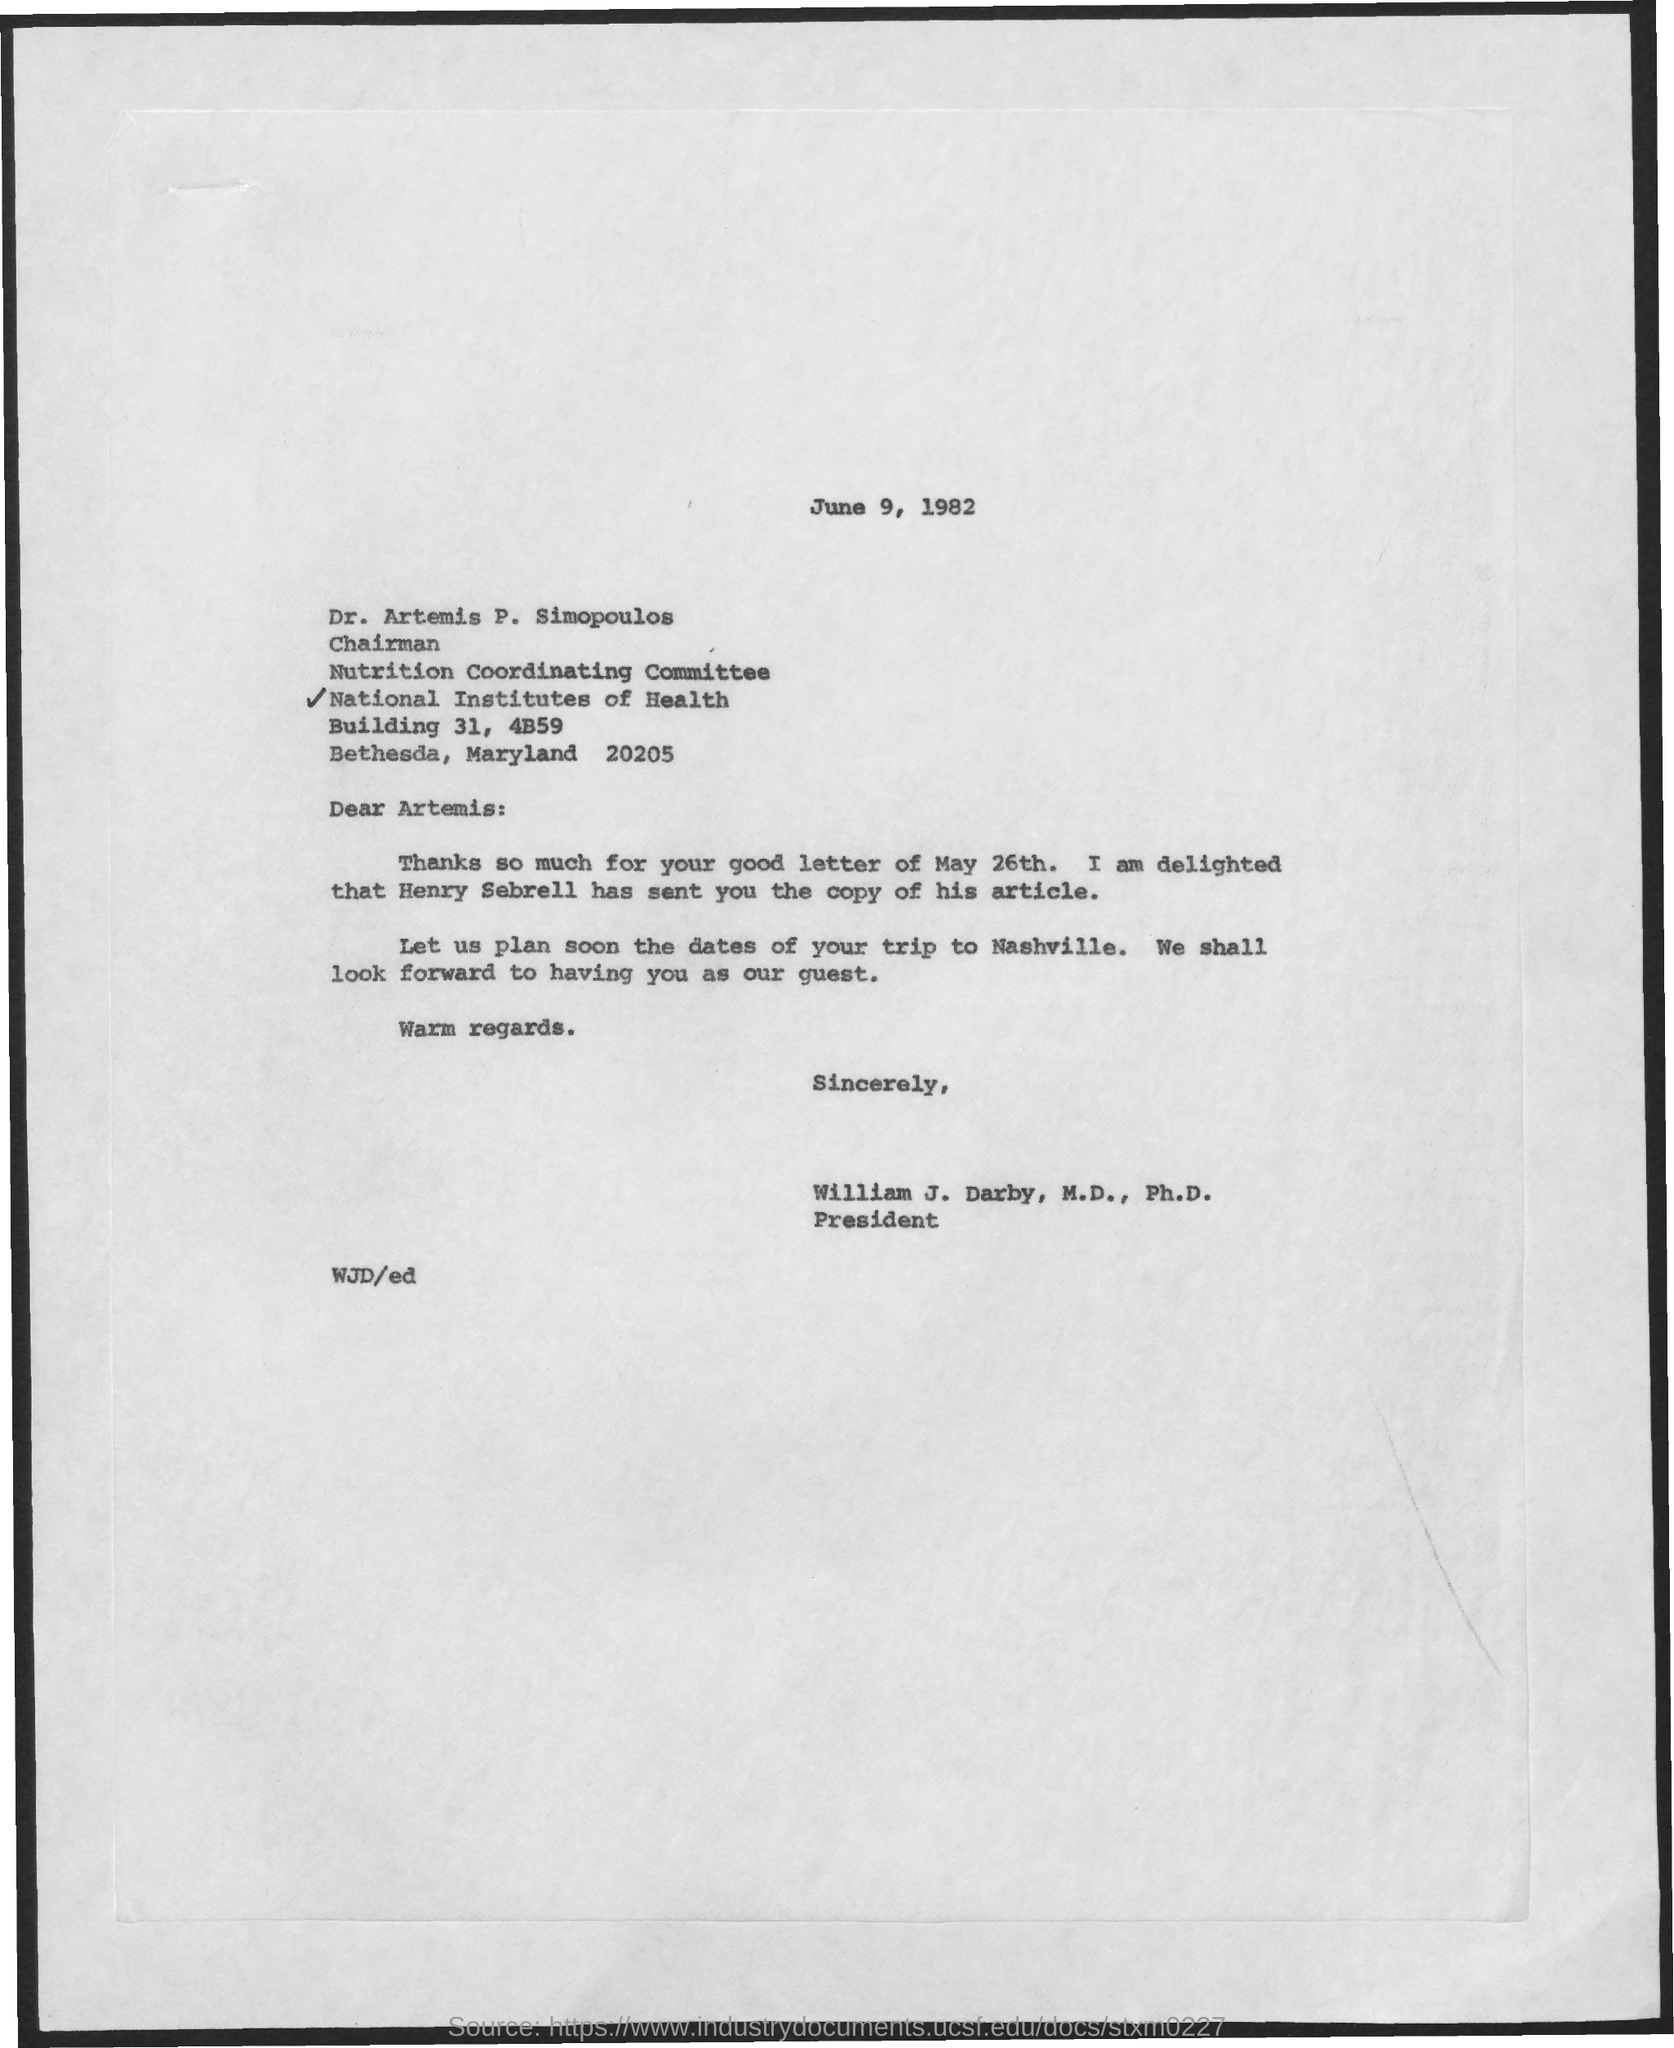Indicate a few pertinent items in this graphic. The date mentioned in the given page is June 9, 1982. Dr. Artemis P. Simopoulos has been designated as the chairman. 